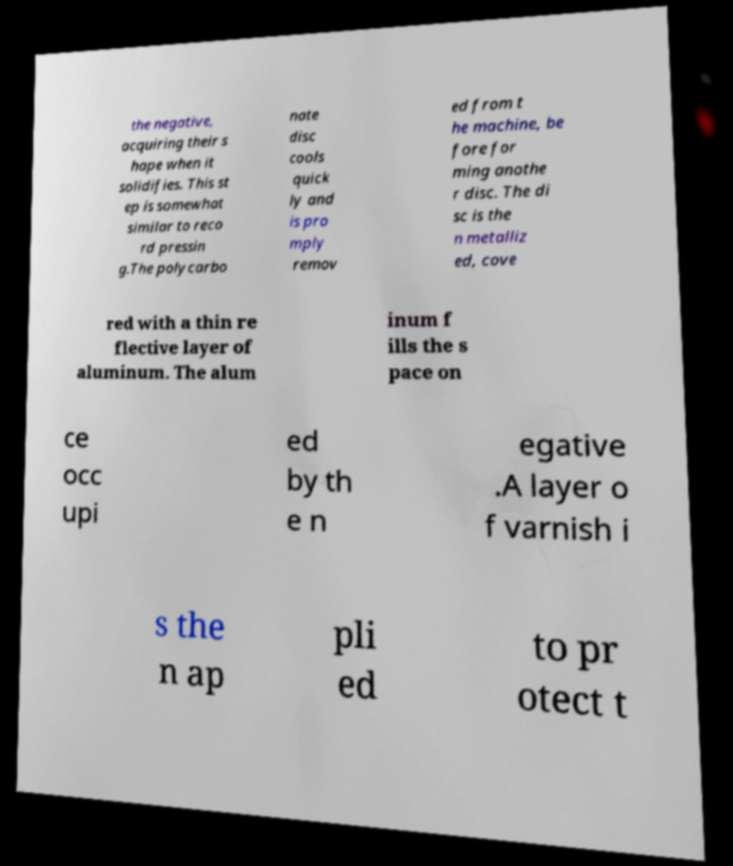I need the written content from this picture converted into text. Can you do that? the negative, acquiring their s hape when it solidifies. This st ep is somewhat similar to reco rd pressin g.The polycarbo nate disc cools quick ly and is pro mply remov ed from t he machine, be fore for ming anothe r disc. The di sc is the n metalliz ed, cove red with a thin re flective layer of aluminum. The alum inum f ills the s pace on ce occ upi ed by th e n egative .A layer o f varnish i s the n ap pli ed to pr otect t 